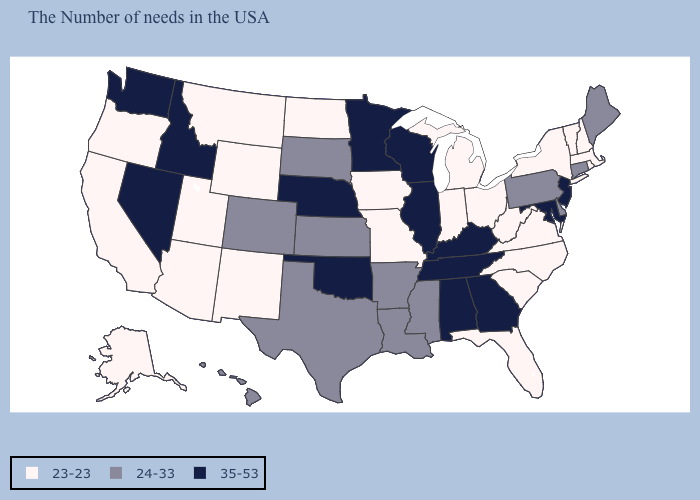Name the states that have a value in the range 24-33?
Quick response, please. Maine, Connecticut, Delaware, Pennsylvania, Mississippi, Louisiana, Arkansas, Kansas, Texas, South Dakota, Colorado, Hawaii. Does North Carolina have the lowest value in the South?
Be succinct. Yes. What is the value of Wyoming?
Short answer required. 23-23. Name the states that have a value in the range 35-53?
Give a very brief answer. New Jersey, Maryland, Georgia, Kentucky, Alabama, Tennessee, Wisconsin, Illinois, Minnesota, Nebraska, Oklahoma, Idaho, Nevada, Washington. What is the lowest value in states that border New York?
Quick response, please. 23-23. What is the value of Iowa?
Keep it brief. 23-23. What is the value of Massachusetts?
Short answer required. 23-23. What is the lowest value in the Northeast?
Quick response, please. 23-23. Among the states that border Connecticut , which have the lowest value?
Concise answer only. Massachusetts, Rhode Island, New York. What is the value of Delaware?
Be succinct. 24-33. What is the lowest value in the MidWest?
Be succinct. 23-23. Which states hav the highest value in the South?
Answer briefly. Maryland, Georgia, Kentucky, Alabama, Tennessee, Oklahoma. What is the value of Arkansas?
Write a very short answer. 24-33. What is the lowest value in states that border New Jersey?
Quick response, please. 23-23. What is the value of New York?
Give a very brief answer. 23-23. 